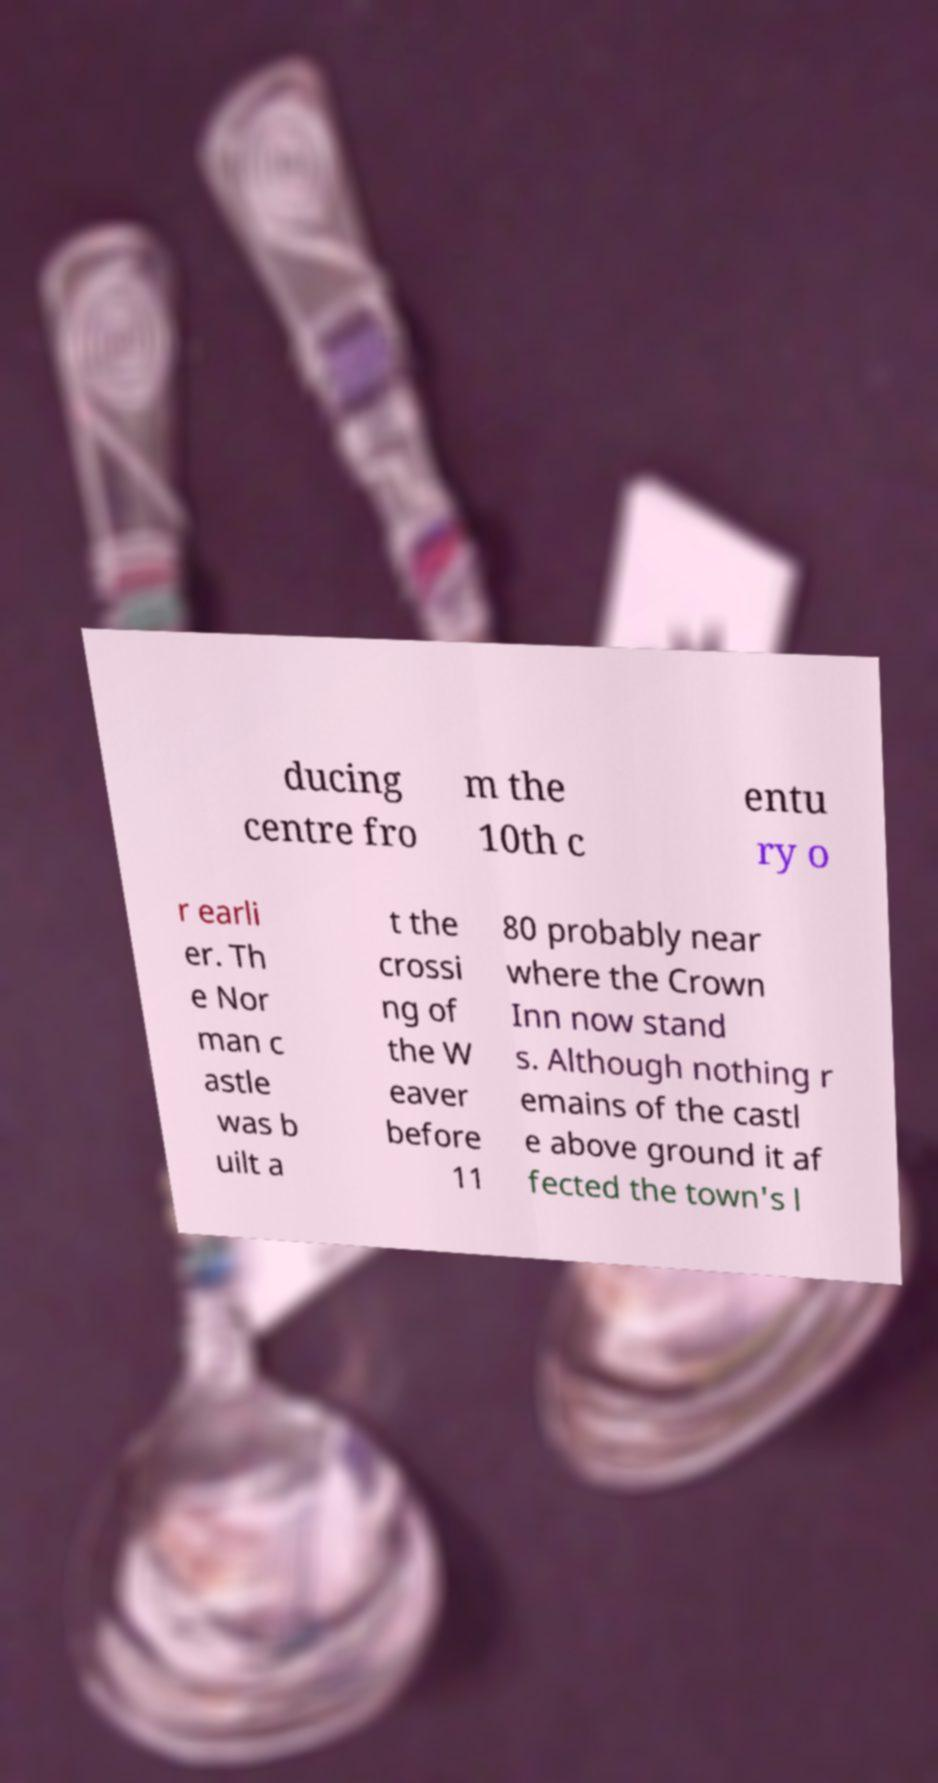There's text embedded in this image that I need extracted. Can you transcribe it verbatim? ducing centre fro m the 10th c entu ry o r earli er. Th e Nor man c astle was b uilt a t the crossi ng of the W eaver before 11 80 probably near where the Crown Inn now stand s. Although nothing r emains of the castl e above ground it af fected the town's l 